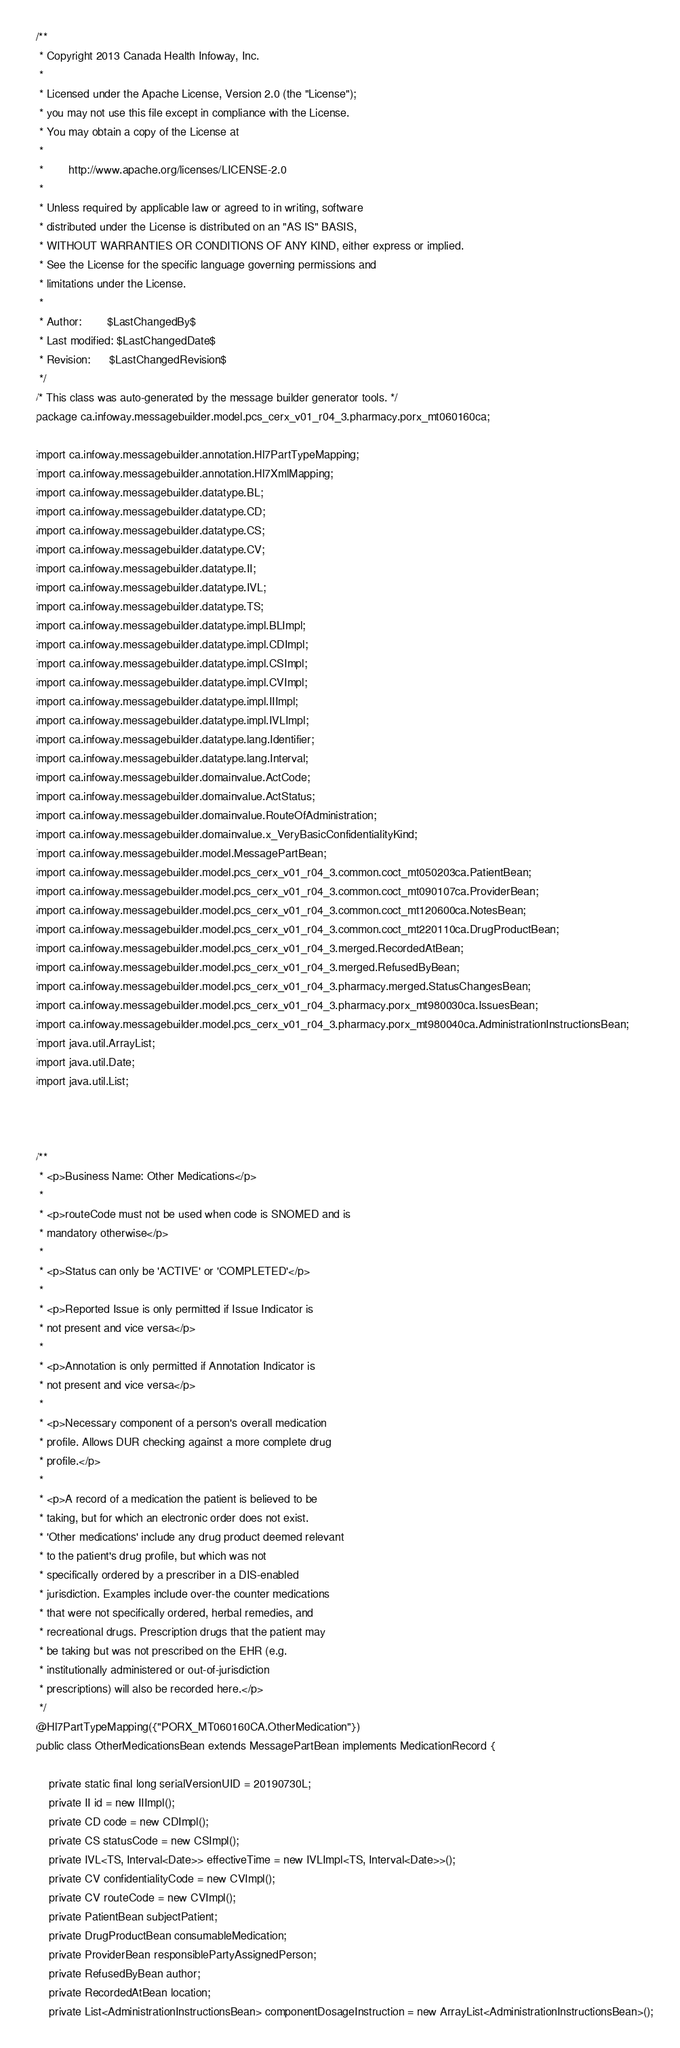<code> <loc_0><loc_0><loc_500><loc_500><_Java_>/**
 * Copyright 2013 Canada Health Infoway, Inc.
 *
 * Licensed under the Apache License, Version 2.0 (the "License");
 * you may not use this file except in compliance with the License.
 * You may obtain a copy of the License at
 *
 *        http://www.apache.org/licenses/LICENSE-2.0
 *
 * Unless required by applicable law or agreed to in writing, software
 * distributed under the License is distributed on an "AS IS" BASIS,
 * WITHOUT WARRANTIES OR CONDITIONS OF ANY KIND, either express or implied.
 * See the License for the specific language governing permissions and
 * limitations under the License.
 *
 * Author:        $LastChangedBy$
 * Last modified: $LastChangedDate$
 * Revision:      $LastChangedRevision$
 */
/* This class was auto-generated by the message builder generator tools. */
package ca.infoway.messagebuilder.model.pcs_cerx_v01_r04_3.pharmacy.porx_mt060160ca;

import ca.infoway.messagebuilder.annotation.Hl7PartTypeMapping;
import ca.infoway.messagebuilder.annotation.Hl7XmlMapping;
import ca.infoway.messagebuilder.datatype.BL;
import ca.infoway.messagebuilder.datatype.CD;
import ca.infoway.messagebuilder.datatype.CS;
import ca.infoway.messagebuilder.datatype.CV;
import ca.infoway.messagebuilder.datatype.II;
import ca.infoway.messagebuilder.datatype.IVL;
import ca.infoway.messagebuilder.datatype.TS;
import ca.infoway.messagebuilder.datatype.impl.BLImpl;
import ca.infoway.messagebuilder.datatype.impl.CDImpl;
import ca.infoway.messagebuilder.datatype.impl.CSImpl;
import ca.infoway.messagebuilder.datatype.impl.CVImpl;
import ca.infoway.messagebuilder.datatype.impl.IIImpl;
import ca.infoway.messagebuilder.datatype.impl.IVLImpl;
import ca.infoway.messagebuilder.datatype.lang.Identifier;
import ca.infoway.messagebuilder.datatype.lang.Interval;
import ca.infoway.messagebuilder.domainvalue.ActCode;
import ca.infoway.messagebuilder.domainvalue.ActStatus;
import ca.infoway.messagebuilder.domainvalue.RouteOfAdministration;
import ca.infoway.messagebuilder.domainvalue.x_VeryBasicConfidentialityKind;
import ca.infoway.messagebuilder.model.MessagePartBean;
import ca.infoway.messagebuilder.model.pcs_cerx_v01_r04_3.common.coct_mt050203ca.PatientBean;
import ca.infoway.messagebuilder.model.pcs_cerx_v01_r04_3.common.coct_mt090107ca.ProviderBean;
import ca.infoway.messagebuilder.model.pcs_cerx_v01_r04_3.common.coct_mt120600ca.NotesBean;
import ca.infoway.messagebuilder.model.pcs_cerx_v01_r04_3.common.coct_mt220110ca.DrugProductBean;
import ca.infoway.messagebuilder.model.pcs_cerx_v01_r04_3.merged.RecordedAtBean;
import ca.infoway.messagebuilder.model.pcs_cerx_v01_r04_3.merged.RefusedByBean;
import ca.infoway.messagebuilder.model.pcs_cerx_v01_r04_3.pharmacy.merged.StatusChangesBean;
import ca.infoway.messagebuilder.model.pcs_cerx_v01_r04_3.pharmacy.porx_mt980030ca.IssuesBean;
import ca.infoway.messagebuilder.model.pcs_cerx_v01_r04_3.pharmacy.porx_mt980040ca.AdministrationInstructionsBean;
import java.util.ArrayList;
import java.util.Date;
import java.util.List;



/**
 * <p>Business Name: Other Medications</p>
 * 
 * <p>routeCode must not be used when code is SNOMED and is 
 * mandatory otherwise</p>
 * 
 * <p>Status can only be 'ACTIVE' or 'COMPLETED'</p>
 * 
 * <p>Reported Issue is only permitted if Issue Indicator is 
 * not present and vice versa</p>
 * 
 * <p>Annotation is only permitted if Annotation Indicator is 
 * not present and vice versa</p>
 * 
 * <p>Necessary component of a person's overall medication 
 * profile. Allows DUR checking against a more complete drug 
 * profile.</p>
 * 
 * <p>A record of a medication the patient is believed to be 
 * taking, but for which an electronic order does not exist. 
 * 'Other medications' include any drug product deemed relevant 
 * to the patient's drug profile, but which was not 
 * specifically ordered by a prescriber in a DIS-enabled 
 * jurisdiction. Examples include over-the counter medications 
 * that were not specifically ordered, herbal remedies, and 
 * recreational drugs. Prescription drugs that the patient may 
 * be taking but was not prescribed on the EHR (e.g. 
 * institutionally administered or out-of-jurisdiction 
 * prescriptions) will also be recorded here.</p>
 */
@Hl7PartTypeMapping({"PORX_MT060160CA.OtherMedication"})
public class OtherMedicationsBean extends MessagePartBean implements MedicationRecord {

    private static final long serialVersionUID = 20190730L;
    private II id = new IIImpl();
    private CD code = new CDImpl();
    private CS statusCode = new CSImpl();
    private IVL<TS, Interval<Date>> effectiveTime = new IVLImpl<TS, Interval<Date>>();
    private CV confidentialityCode = new CVImpl();
    private CV routeCode = new CVImpl();
    private PatientBean subjectPatient;
    private DrugProductBean consumableMedication;
    private ProviderBean responsiblePartyAssignedPerson;
    private RefusedByBean author;
    private RecordedAtBean location;
    private List<AdministrationInstructionsBean> componentDosageInstruction = new ArrayList<AdministrationInstructionsBean>();</code> 